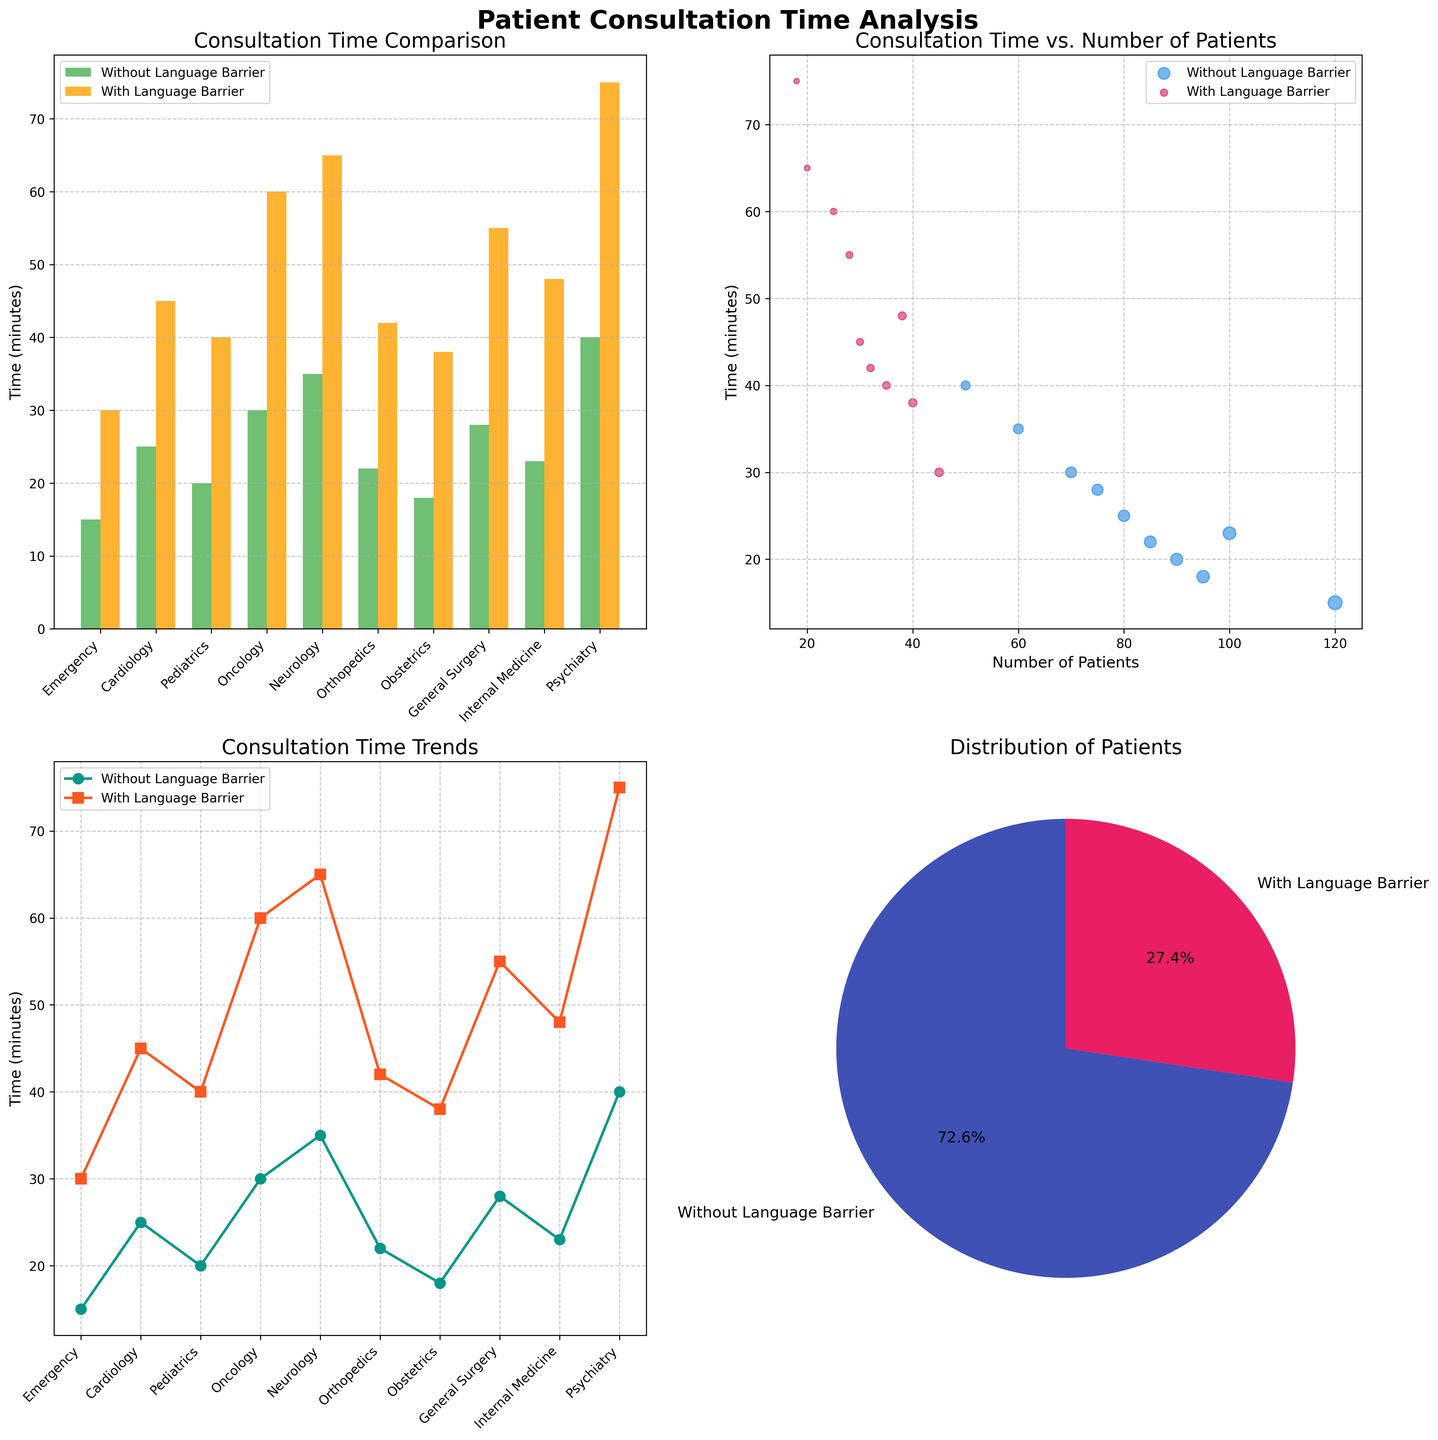What is the title of the first subplot? The first subplot refers to the bar plot in the top-left corner. The title is located above the x-axis, displaying the topic of the subplot. The title reads 'Consultation Time Comparison'.
Answer: Consultation Time Comparison How many departments are displayed in the figure? The data related to various medical departments is presented on the x-axis of the subplots (e.g., bar plot and line plot). Each department is labeled there. Counting all the labels, we find there are 10 departments.
Answer: 10 departments Which department shows the largest increase in consultation time due to language barriers in the line plot? The line plot visualizes the consultation times with markers for each department. Identify the largest vertical gap between the two lines (Time Without Barrier and Time With Barrier). Neurology demonstrates the largest increase, rising from 35 to 65 minutes.
Answer: Neurology What is the average consultation time with language barriers across all departments? To find this, sum the consultation times with barriers from all departments: (30 + 45 + 40 + 60 + 65 + 42 + 38 + 55 + 48 + 75) = 498 minutes. Then divide by the number of departments, 10. So, 498/10 = 49.8 minutes.
Answer: 49.8 minutes Which type of chart is used to display the distribution of patients? The pie chart in the bottom-right corner visualizes the distribution of patients. Each slice represents a portion of the total number of patients.
Answer: Pie chart In the scatter plot, which patient group tends to have shorter consultation times? In the scatter plot, two distinct clusters are visible. The group labeled 'Without Language Barrier' (in blue) consistently shows lower times on the y-axis compared to the 'With Language Barrier' group (in red).
Answer: Without Language Barrier What proportion of total patients has language barriers according to the pie chart? The pie chart displays two slices, with percentages indicating the proportion. The slice representing 'With Language Barrier' is labeled with '24.1%', reflecting the proportion of patients with language barriers.
Answer: 24.1% What trend does the line plot suggest about the impact of language barriers on consultation time across departments? The line plot shows two lines for Time Without Barrier and Time With Barrier. The two lines indicate that in every department, the Time With Barrier is higher, suggesting that language barriers increase consultation time.
Answer: Language barriers increase consultation time Compare the total number of patients with and without language barriers. The pie chart provides percentages for patient distribution. Summing the absolute number of patients from the data, we get 825 patients without barriers and 311 with barriers. Converting these to percentages yields approximately 72.6% and 27.4%, respectively. Cross-checking these with the pie chart reveals consistency with our calculations.
Answer: More patients without barriers Which department serves the highest number of patients without language barriers according to the scatter plot? The scatter plot uses marker size to represent the number of patients. The largest blue marker indicates the department with the most patients without language barriers. In this case, Obstetrics serves the highest number (95).
Answer: Obstetrics 